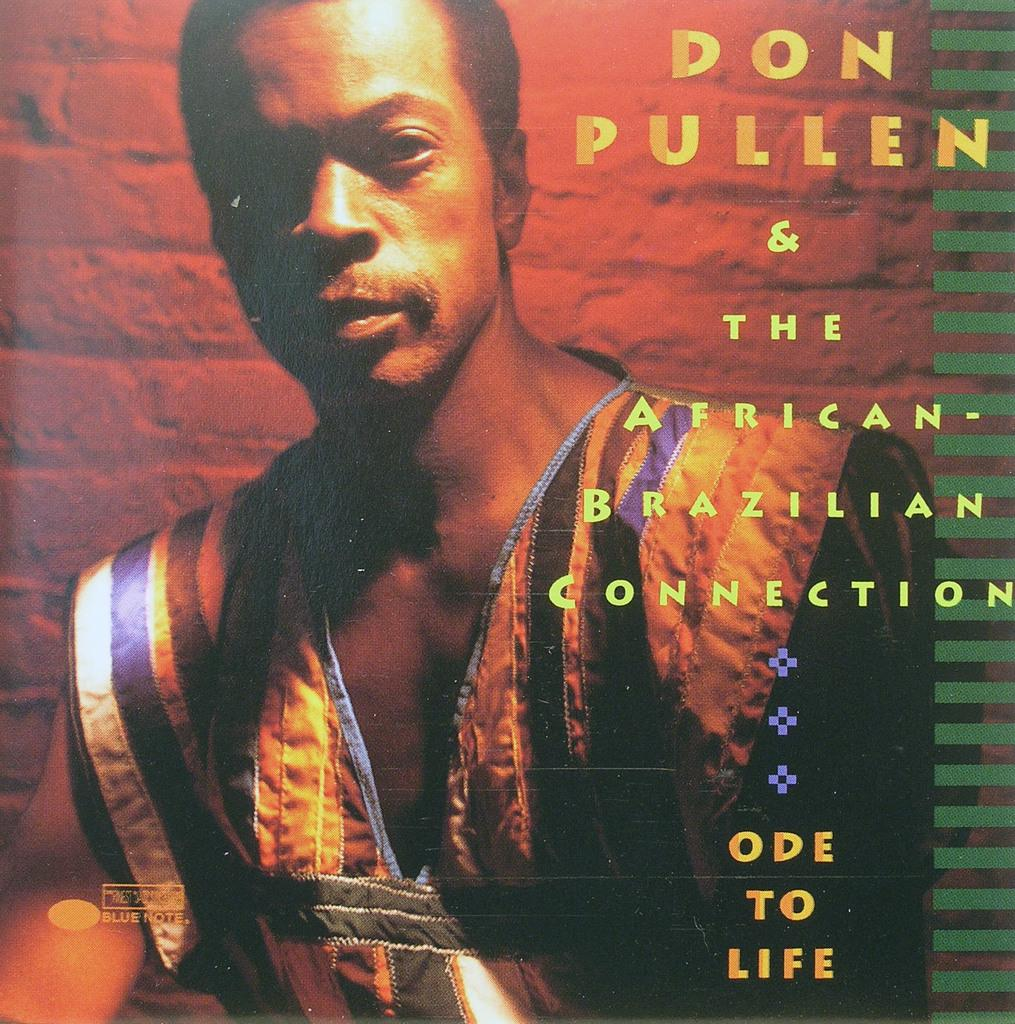<image>
Provide a brief description of the given image. Don Pullen and The African-Brazilian Connection released "Ode to Life". 